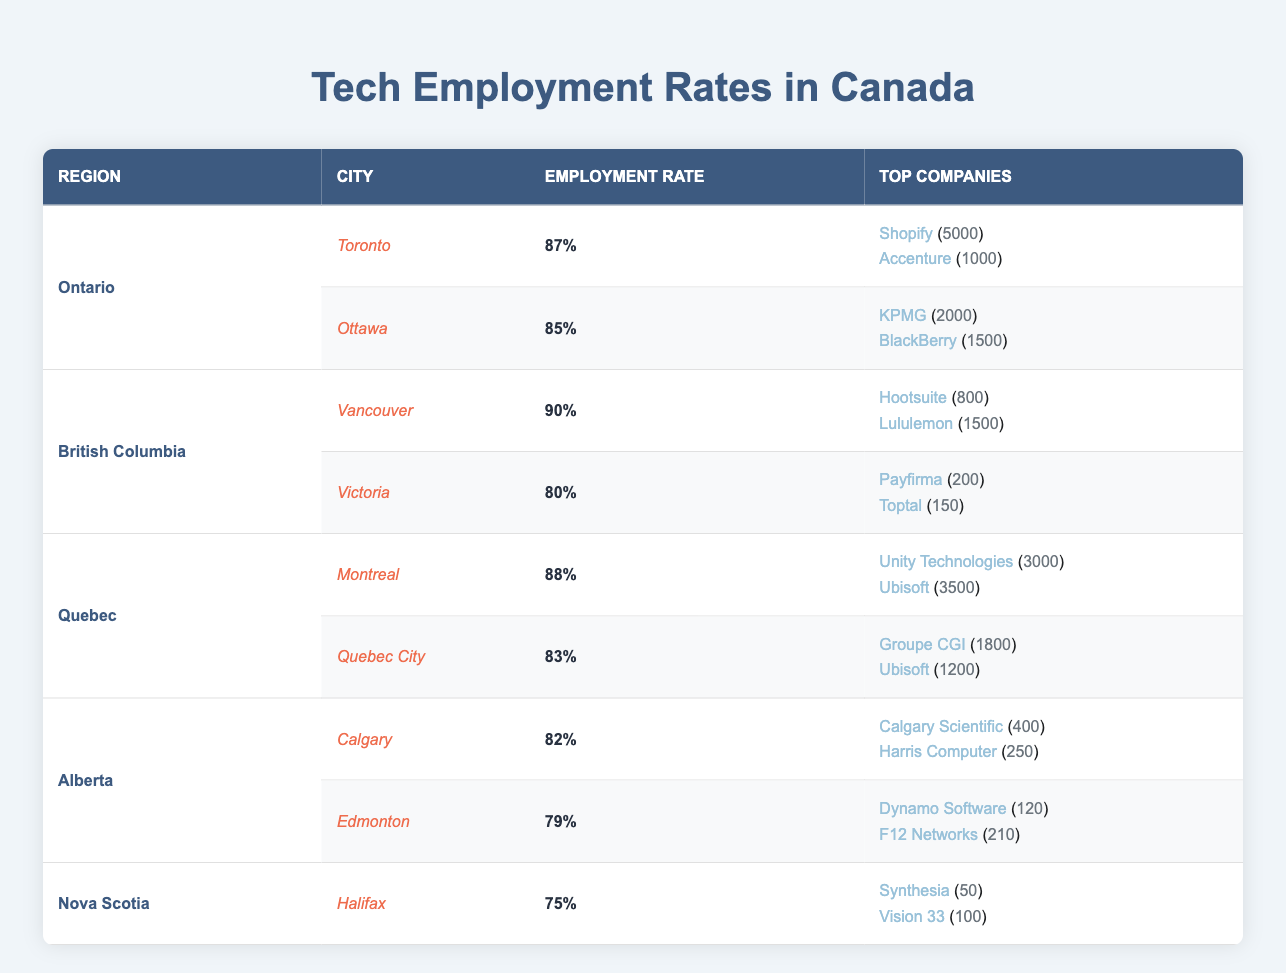What is the employment rate in Toronto? The table lists the employment rate for Toronto under Ontario. It states that the employment rate for Toronto is 87%.
Answer: 87% Which city has the highest employment rate in the technology sector? By comparing all the employment rates listed, Vancouver has the highest rate at 90%.
Answer: Vancouver What is the total number of employees at the top companies in Montreal? In Montreal, the companies listed are Unity Technologies (3000 employees) and Ubisoft (3500 employees). Adding these gives a total of 3000 + 3500 = 6500 employees.
Answer: 6500 Is the employment rate in Halifax above 80%? In the table, Halifax has an employment rate of 75%, which is below 80%. Therefore, the answer is no.
Answer: No What is the difference in employment rates between Victoria and Ottawa? Victoria has an employment rate of 80% and Ottawa has an employment rate of 85%. The difference is calculated by subtracting 80% from 85%, resulting in 85% - 80% = 5%.
Answer: 5% What are the total employees in Alberta's tech companies? In Calgary, the total employees are 400 (Calgary Scientific) + 250 (Harris Computer) = 650. In Edmonton, the total is 120 (Dynamo Software) + 210 (F12 Networks) = 330. Adding both sums gives 650 + 330 = 980 employees in total for Alberta.
Answer: 980 True or false: Ubisoft operates in both Montreal and Quebec City. The table shows that Ubisoft is listed as a top company in both Montreal and Quebec City, confirming the statement as true.
Answer: True Which province has the lowest employment rate in the technology sector? Comparing the employment rates, Halifax (Nova Scotia) has the lowest employment rate of 75% among all listed provinces and cities.
Answer: Nova Scotia How many top companies are listed for Edmonton? Edmonton has two top companies listed: Dynamo Software and F12 Networks. Therefore, the answer is two.
Answer: 2 What is the combined employment of the top companies in Ottawa? In Ottawa, KPMG has 2000 employees and BlackBerry has 1500. Adding these gives 2000 + 1500 = 3500 employees in total.
Answer: 3500 If we compare all cities, how many have employment rates below 80%? The table shows that Halifax (75%) and Edmonton (79%) are the only cities with employment rates below 80%. Therefore, there are two cities.
Answer: 2 